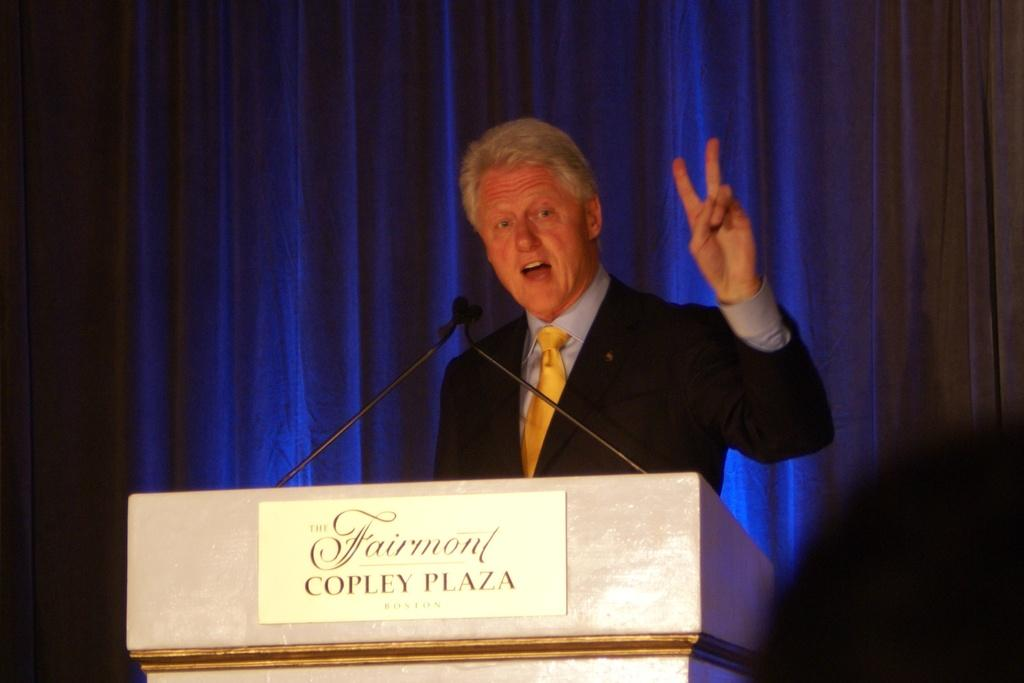Provide a one-sentence caption for the provided image. President Clinton stands behind a podium with a sign that reads Fairmont Copley Plaza. 